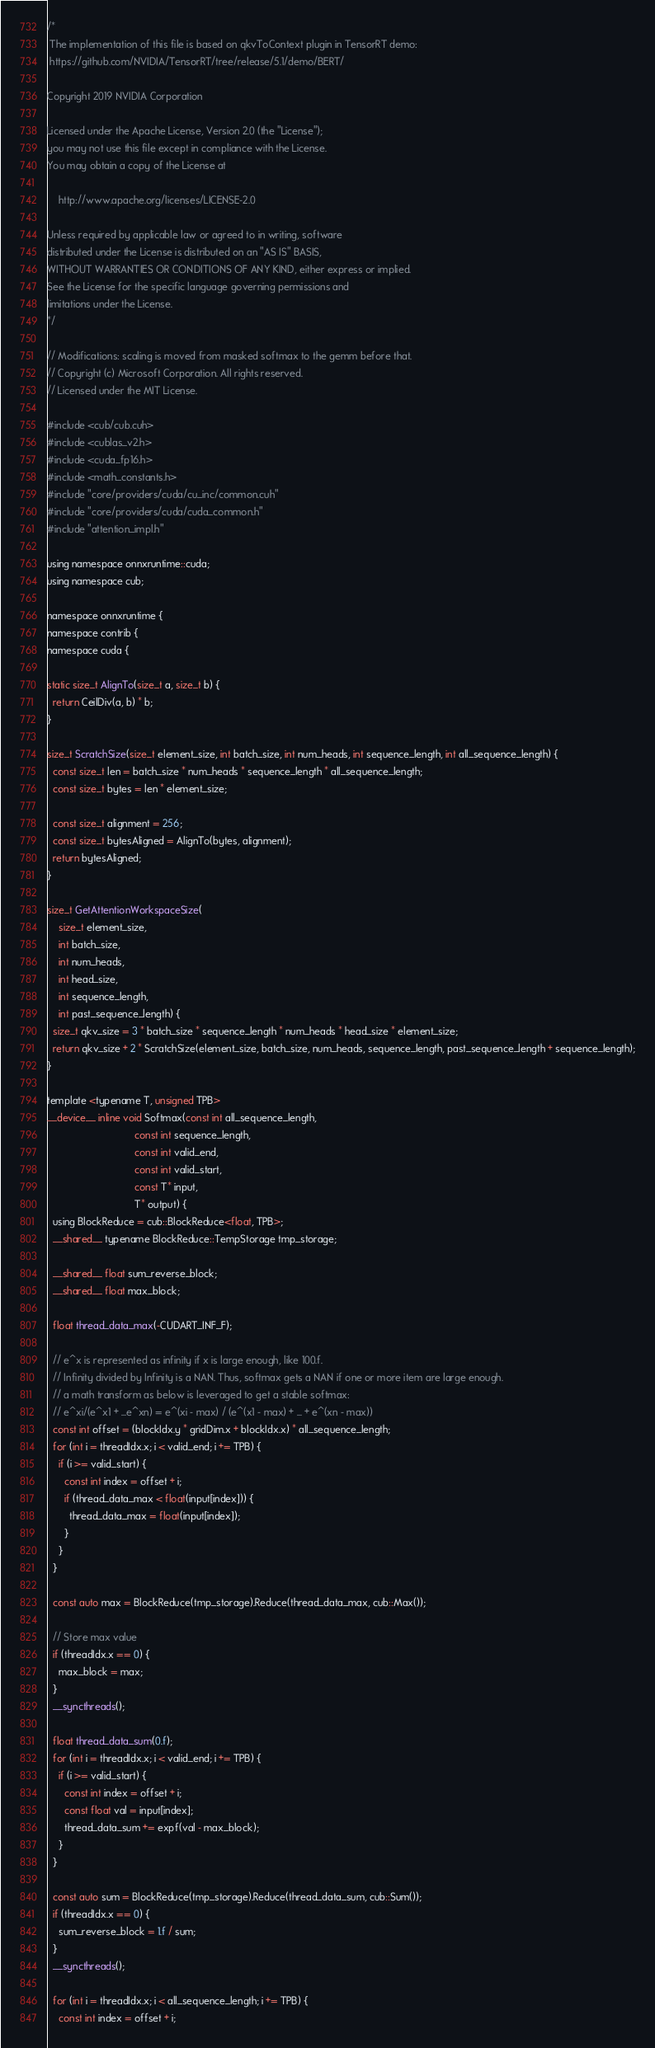Convert code to text. <code><loc_0><loc_0><loc_500><loc_500><_Cuda_>/*
 The implementation of this file is based on qkvToContext plugin in TensorRT demo:
 https://github.com/NVIDIA/TensorRT/tree/release/5.1/demo/BERT/

Copyright 2019 NVIDIA Corporation

Licensed under the Apache License, Version 2.0 (the "License");
you may not use this file except in compliance with the License.
You may obtain a copy of the License at

    http://www.apache.org/licenses/LICENSE-2.0

Unless required by applicable law or agreed to in writing, software
distributed under the License is distributed on an "AS IS" BASIS,
WITHOUT WARRANTIES OR CONDITIONS OF ANY KIND, either express or implied.
See the License for the specific language governing permissions and
limitations under the License.
*/

// Modifications: scaling is moved from masked softmax to the gemm before that.
// Copyright (c) Microsoft Corporation. All rights reserved.
// Licensed under the MIT License.

#include <cub/cub.cuh>
#include <cublas_v2.h>
#include <cuda_fp16.h>
#include <math_constants.h>
#include "core/providers/cuda/cu_inc/common.cuh"
#include "core/providers/cuda/cuda_common.h"
#include "attention_impl.h"

using namespace onnxruntime::cuda;
using namespace cub;

namespace onnxruntime {
namespace contrib {
namespace cuda {

static size_t AlignTo(size_t a, size_t b) {
  return CeilDiv(a, b) * b;
}

size_t ScratchSize(size_t element_size, int batch_size, int num_heads, int sequence_length, int all_sequence_length) {
  const size_t len = batch_size * num_heads * sequence_length * all_sequence_length;
  const size_t bytes = len * element_size;

  const size_t alignment = 256;
  const size_t bytesAligned = AlignTo(bytes, alignment);
  return bytesAligned;
}

size_t GetAttentionWorkspaceSize(
    size_t element_size,
    int batch_size,
    int num_heads,
    int head_size,
    int sequence_length,
    int past_sequence_length) {
  size_t qkv_size = 3 * batch_size * sequence_length * num_heads * head_size * element_size;
  return qkv_size + 2 * ScratchSize(element_size, batch_size, num_heads, sequence_length, past_sequence_length + sequence_length);
}

template <typename T, unsigned TPB>
__device__ inline void Softmax(const int all_sequence_length,
                               const int sequence_length,
                               const int valid_end,
                               const int valid_start,
                               const T* input,
                               T* output) {
  using BlockReduce = cub::BlockReduce<float, TPB>;
  __shared__ typename BlockReduce::TempStorage tmp_storage;

  __shared__ float sum_reverse_block;
  __shared__ float max_block;

  float thread_data_max(-CUDART_INF_F);

  // e^x is represented as infinity if x is large enough, like 100.f.
  // Infinity divided by Infinity is a NAN. Thus, softmax gets a NAN if one or more item are large enough.
  // a math transform as below is leveraged to get a stable softmax:
  // e^xi/(e^x1 + ...e^xn) = e^(xi - max) / (e^(x1 - max) + ... + e^(xn - max))
  const int offset = (blockIdx.y * gridDim.x + blockIdx.x) * all_sequence_length;
  for (int i = threadIdx.x; i < valid_end; i += TPB) {
    if (i >= valid_start) {
      const int index = offset + i;
      if (thread_data_max < float(input[index])) {
        thread_data_max = float(input[index]);
      }
    }
  }

  const auto max = BlockReduce(tmp_storage).Reduce(thread_data_max, cub::Max());

  // Store max value
  if (threadIdx.x == 0) {
    max_block = max;
  }
  __syncthreads();

  float thread_data_sum(0.f);
  for (int i = threadIdx.x; i < valid_end; i += TPB) {
    if (i >= valid_start) {
      const int index = offset + i;
      const float val = input[index];
      thread_data_sum += expf(val - max_block);
    }
  }

  const auto sum = BlockReduce(tmp_storage).Reduce(thread_data_sum, cub::Sum());
  if (threadIdx.x == 0) {
    sum_reverse_block = 1.f / sum;
  }
  __syncthreads();

  for (int i = threadIdx.x; i < all_sequence_length; i += TPB) {
    const int index = offset + i;</code> 